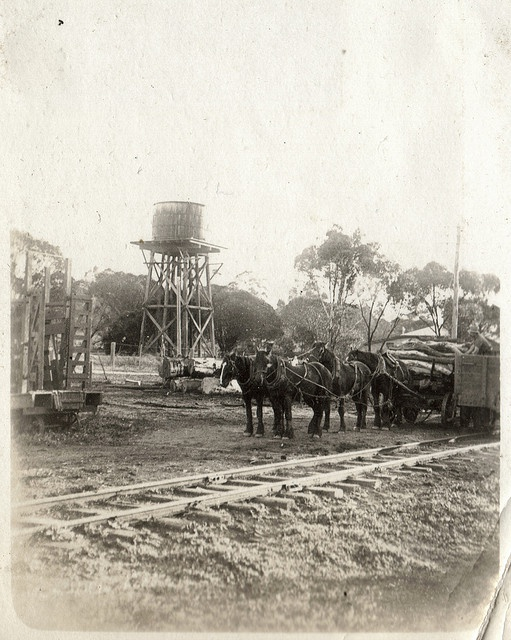Describe the objects in this image and their specific colors. I can see horse in ivory, black, and gray tones, train in ivory, gray, and black tones, horse in ivory, black, and gray tones, horse in ivory, black, gray, and darkgray tones, and horse in ivory, black, gray, and darkgray tones in this image. 